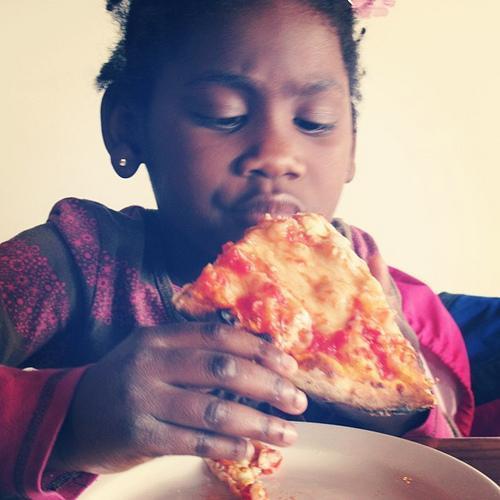How many people are in the photo?
Give a very brief answer. 1. How many earrings are visible in the picture?
Give a very brief answer. 1. 